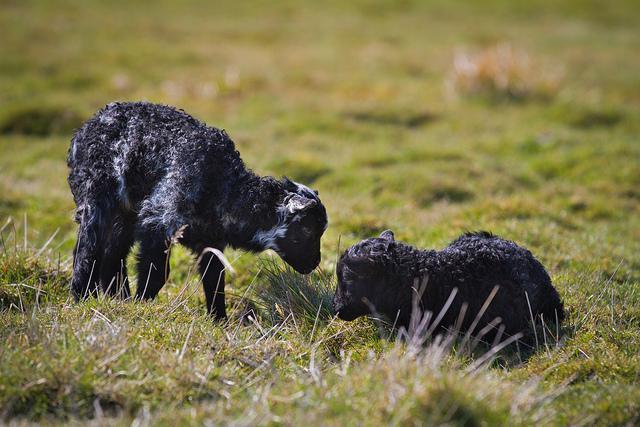How many sheep are visible?
Give a very brief answer. 2. 